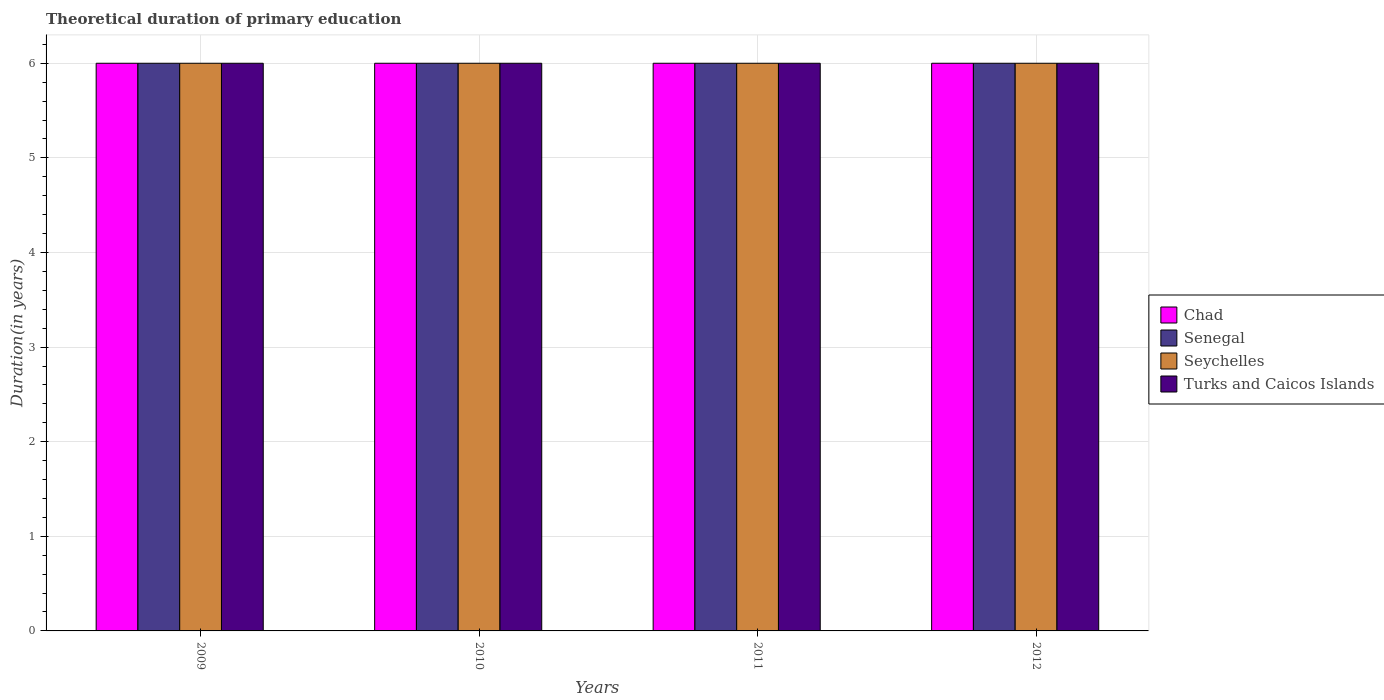How many groups of bars are there?
Your answer should be compact. 4. Are the number of bars per tick equal to the number of legend labels?
Your answer should be compact. Yes. What is the total theoretical duration of primary education in Chad in 2012?
Your answer should be compact. 6. Across all years, what is the minimum total theoretical duration of primary education in Seychelles?
Offer a very short reply. 6. What is the total total theoretical duration of primary education in Turks and Caicos Islands in the graph?
Your answer should be very brief. 24. What is the average total theoretical duration of primary education in Chad per year?
Ensure brevity in your answer.  6. In the year 2010, what is the difference between the total theoretical duration of primary education in Chad and total theoretical duration of primary education in Turks and Caicos Islands?
Offer a very short reply. 0. What is the ratio of the total theoretical duration of primary education in Chad in 2009 to that in 2011?
Keep it short and to the point. 1. Is it the case that in every year, the sum of the total theoretical duration of primary education in Chad and total theoretical duration of primary education in Senegal is greater than the sum of total theoretical duration of primary education in Seychelles and total theoretical duration of primary education in Turks and Caicos Islands?
Keep it short and to the point. No. What does the 2nd bar from the left in 2011 represents?
Give a very brief answer. Senegal. What does the 3rd bar from the right in 2012 represents?
Ensure brevity in your answer.  Senegal. Is it the case that in every year, the sum of the total theoretical duration of primary education in Chad and total theoretical duration of primary education in Turks and Caicos Islands is greater than the total theoretical duration of primary education in Senegal?
Your answer should be compact. Yes. Are all the bars in the graph horizontal?
Your answer should be compact. No. What is the difference between two consecutive major ticks on the Y-axis?
Give a very brief answer. 1. Does the graph contain grids?
Offer a very short reply. Yes. Where does the legend appear in the graph?
Your answer should be very brief. Center right. What is the title of the graph?
Give a very brief answer. Theoretical duration of primary education. What is the label or title of the Y-axis?
Ensure brevity in your answer.  Duration(in years). What is the Duration(in years) of Chad in 2009?
Offer a very short reply. 6. What is the Duration(in years) in Senegal in 2009?
Provide a succinct answer. 6. What is the Duration(in years) in Seychelles in 2009?
Offer a very short reply. 6. What is the Duration(in years) in Seychelles in 2010?
Make the answer very short. 6. What is the Duration(in years) of Seychelles in 2011?
Provide a succinct answer. 6. What is the Duration(in years) in Turks and Caicos Islands in 2011?
Your answer should be very brief. 6. What is the Duration(in years) in Senegal in 2012?
Your answer should be very brief. 6. What is the Duration(in years) of Seychelles in 2012?
Your answer should be compact. 6. What is the Duration(in years) of Turks and Caicos Islands in 2012?
Ensure brevity in your answer.  6. Across all years, what is the maximum Duration(in years) of Chad?
Give a very brief answer. 6. Across all years, what is the maximum Duration(in years) of Senegal?
Give a very brief answer. 6. Across all years, what is the maximum Duration(in years) of Seychelles?
Offer a terse response. 6. Across all years, what is the maximum Duration(in years) of Turks and Caicos Islands?
Ensure brevity in your answer.  6. What is the total Duration(in years) in Chad in the graph?
Your answer should be compact. 24. What is the total Duration(in years) in Senegal in the graph?
Offer a terse response. 24. What is the total Duration(in years) in Seychelles in the graph?
Give a very brief answer. 24. What is the total Duration(in years) in Turks and Caicos Islands in the graph?
Give a very brief answer. 24. What is the difference between the Duration(in years) in Chad in 2009 and that in 2010?
Ensure brevity in your answer.  0. What is the difference between the Duration(in years) of Seychelles in 2009 and that in 2010?
Your answer should be compact. 0. What is the difference between the Duration(in years) in Turks and Caicos Islands in 2009 and that in 2010?
Provide a succinct answer. 0. What is the difference between the Duration(in years) of Senegal in 2009 and that in 2011?
Offer a very short reply. 0. What is the difference between the Duration(in years) in Turks and Caicos Islands in 2009 and that in 2011?
Your answer should be very brief. 0. What is the difference between the Duration(in years) in Chad in 2009 and that in 2012?
Offer a very short reply. 0. What is the difference between the Duration(in years) of Senegal in 2009 and that in 2012?
Give a very brief answer. 0. What is the difference between the Duration(in years) in Turks and Caicos Islands in 2009 and that in 2012?
Offer a terse response. 0. What is the difference between the Duration(in years) of Chad in 2010 and that in 2011?
Offer a very short reply. 0. What is the difference between the Duration(in years) of Senegal in 2010 and that in 2011?
Provide a short and direct response. 0. What is the difference between the Duration(in years) of Seychelles in 2010 and that in 2011?
Provide a short and direct response. 0. What is the difference between the Duration(in years) of Chad in 2010 and that in 2012?
Keep it short and to the point. 0. What is the difference between the Duration(in years) in Senegal in 2010 and that in 2012?
Offer a terse response. 0. What is the difference between the Duration(in years) of Turks and Caicos Islands in 2010 and that in 2012?
Your answer should be compact. 0. What is the difference between the Duration(in years) of Chad in 2011 and that in 2012?
Your answer should be compact. 0. What is the difference between the Duration(in years) of Senegal in 2011 and that in 2012?
Give a very brief answer. 0. What is the difference between the Duration(in years) in Seychelles in 2011 and that in 2012?
Give a very brief answer. 0. What is the difference between the Duration(in years) in Chad in 2009 and the Duration(in years) in Turks and Caicos Islands in 2010?
Your answer should be very brief. 0. What is the difference between the Duration(in years) in Senegal in 2009 and the Duration(in years) in Turks and Caicos Islands in 2010?
Offer a terse response. 0. What is the difference between the Duration(in years) in Seychelles in 2009 and the Duration(in years) in Turks and Caicos Islands in 2010?
Provide a short and direct response. 0. What is the difference between the Duration(in years) of Chad in 2009 and the Duration(in years) of Senegal in 2011?
Offer a terse response. 0. What is the difference between the Duration(in years) in Chad in 2009 and the Duration(in years) in Turks and Caicos Islands in 2011?
Offer a very short reply. 0. What is the difference between the Duration(in years) in Senegal in 2009 and the Duration(in years) in Seychelles in 2011?
Provide a short and direct response. 0. What is the difference between the Duration(in years) in Seychelles in 2009 and the Duration(in years) in Turks and Caicos Islands in 2011?
Your answer should be very brief. 0. What is the difference between the Duration(in years) of Chad in 2009 and the Duration(in years) of Senegal in 2012?
Keep it short and to the point. 0. What is the difference between the Duration(in years) in Chad in 2009 and the Duration(in years) in Seychelles in 2012?
Offer a very short reply. 0. What is the difference between the Duration(in years) of Senegal in 2009 and the Duration(in years) of Turks and Caicos Islands in 2012?
Give a very brief answer. 0. What is the difference between the Duration(in years) in Chad in 2010 and the Duration(in years) in Senegal in 2011?
Keep it short and to the point. 0. What is the difference between the Duration(in years) in Chad in 2010 and the Duration(in years) in Seychelles in 2011?
Your answer should be very brief. 0. What is the difference between the Duration(in years) of Chad in 2010 and the Duration(in years) of Turks and Caicos Islands in 2011?
Your answer should be very brief. 0. What is the difference between the Duration(in years) in Senegal in 2010 and the Duration(in years) in Turks and Caicos Islands in 2011?
Your answer should be compact. 0. What is the difference between the Duration(in years) of Seychelles in 2010 and the Duration(in years) of Turks and Caicos Islands in 2011?
Your response must be concise. 0. What is the difference between the Duration(in years) of Chad in 2010 and the Duration(in years) of Senegal in 2012?
Offer a very short reply. 0. What is the difference between the Duration(in years) in Chad in 2010 and the Duration(in years) in Seychelles in 2012?
Offer a terse response. 0. What is the difference between the Duration(in years) of Chad in 2010 and the Duration(in years) of Turks and Caicos Islands in 2012?
Your answer should be very brief. 0. What is the difference between the Duration(in years) in Senegal in 2010 and the Duration(in years) in Seychelles in 2012?
Keep it short and to the point. 0. What is the difference between the Duration(in years) of Seychelles in 2010 and the Duration(in years) of Turks and Caicos Islands in 2012?
Your response must be concise. 0. What is the average Duration(in years) of Seychelles per year?
Your response must be concise. 6. In the year 2009, what is the difference between the Duration(in years) in Senegal and Duration(in years) in Seychelles?
Provide a short and direct response. 0. In the year 2009, what is the difference between the Duration(in years) in Senegal and Duration(in years) in Turks and Caicos Islands?
Your answer should be very brief. 0. In the year 2009, what is the difference between the Duration(in years) of Seychelles and Duration(in years) of Turks and Caicos Islands?
Keep it short and to the point. 0. In the year 2010, what is the difference between the Duration(in years) of Chad and Duration(in years) of Seychelles?
Your answer should be very brief. 0. In the year 2010, what is the difference between the Duration(in years) in Senegal and Duration(in years) in Seychelles?
Your answer should be very brief. 0. In the year 2011, what is the difference between the Duration(in years) in Chad and Duration(in years) in Senegal?
Provide a succinct answer. 0. In the year 2011, what is the difference between the Duration(in years) of Chad and Duration(in years) of Seychelles?
Give a very brief answer. 0. In the year 2011, what is the difference between the Duration(in years) of Chad and Duration(in years) of Turks and Caicos Islands?
Your answer should be very brief. 0. In the year 2011, what is the difference between the Duration(in years) of Senegal and Duration(in years) of Seychelles?
Ensure brevity in your answer.  0. In the year 2011, what is the difference between the Duration(in years) in Senegal and Duration(in years) in Turks and Caicos Islands?
Provide a succinct answer. 0. In the year 2012, what is the difference between the Duration(in years) in Senegal and Duration(in years) in Seychelles?
Offer a terse response. 0. In the year 2012, what is the difference between the Duration(in years) of Senegal and Duration(in years) of Turks and Caicos Islands?
Offer a very short reply. 0. What is the ratio of the Duration(in years) in Senegal in 2009 to that in 2011?
Make the answer very short. 1. What is the ratio of the Duration(in years) of Seychelles in 2009 to that in 2011?
Offer a terse response. 1. What is the ratio of the Duration(in years) of Turks and Caicos Islands in 2009 to that in 2011?
Offer a terse response. 1. What is the ratio of the Duration(in years) of Senegal in 2009 to that in 2012?
Your answer should be very brief. 1. What is the ratio of the Duration(in years) in Seychelles in 2009 to that in 2012?
Give a very brief answer. 1. What is the ratio of the Duration(in years) in Turks and Caicos Islands in 2009 to that in 2012?
Make the answer very short. 1. What is the ratio of the Duration(in years) of Senegal in 2010 to that in 2011?
Your answer should be compact. 1. What is the ratio of the Duration(in years) in Seychelles in 2010 to that in 2011?
Make the answer very short. 1. What is the ratio of the Duration(in years) in Turks and Caicos Islands in 2010 to that in 2011?
Give a very brief answer. 1. What is the ratio of the Duration(in years) in Seychelles in 2010 to that in 2012?
Provide a succinct answer. 1. What is the ratio of the Duration(in years) of Senegal in 2011 to that in 2012?
Offer a very short reply. 1. What is the difference between the highest and the second highest Duration(in years) of Senegal?
Make the answer very short. 0. What is the difference between the highest and the second highest Duration(in years) in Seychelles?
Make the answer very short. 0. What is the difference between the highest and the lowest Duration(in years) in Chad?
Make the answer very short. 0. 